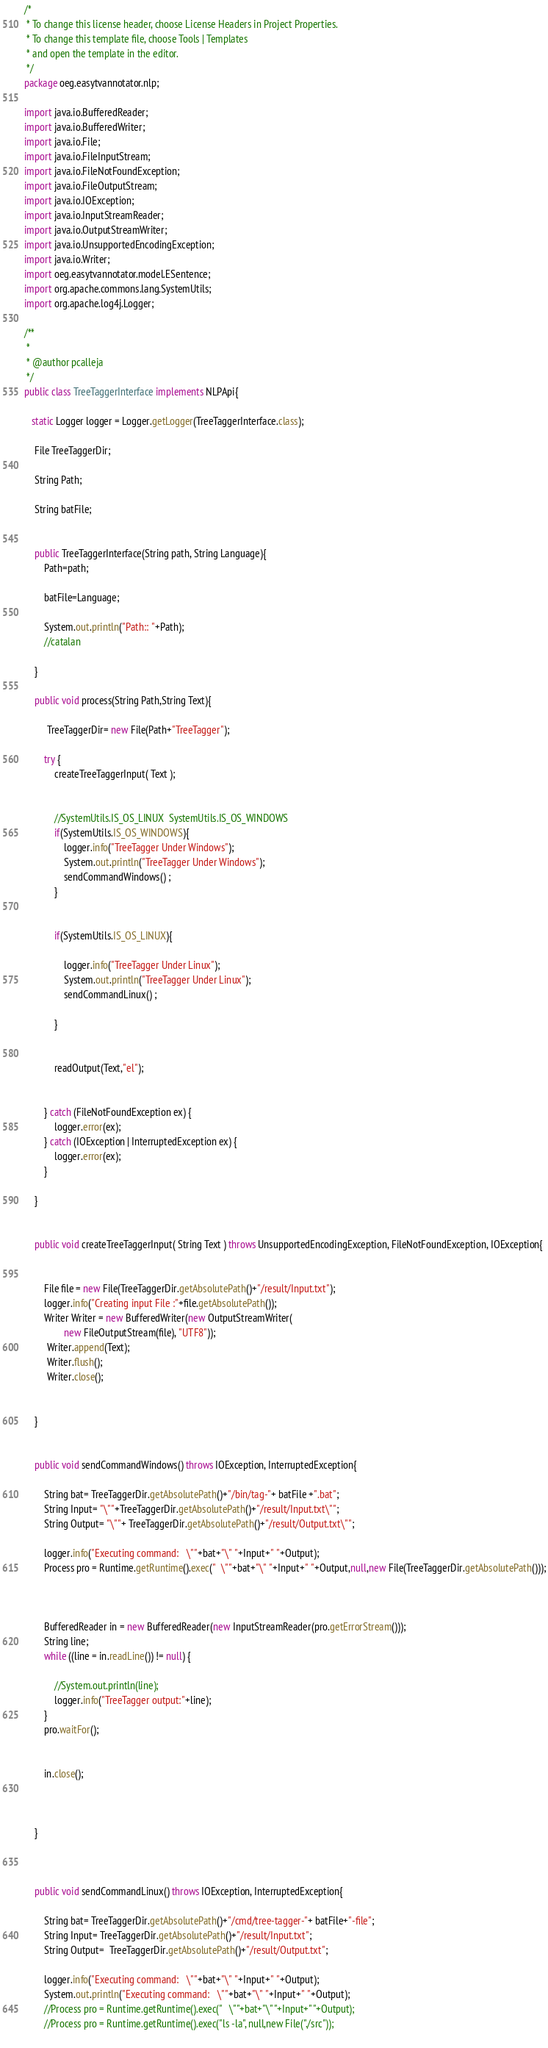Convert code to text. <code><loc_0><loc_0><loc_500><loc_500><_Java_>/*
 * To change this license header, choose License Headers in Project Properties.
 * To change this template file, choose Tools | Templates
 * and open the template in the editor.
 */
package oeg.easytvannotator.nlp;

import java.io.BufferedReader;
import java.io.BufferedWriter;
import java.io.File;
import java.io.FileInputStream;
import java.io.FileNotFoundException;
import java.io.FileOutputStream;
import java.io.IOException;
import java.io.InputStreamReader;
import java.io.OutputStreamWriter;
import java.io.UnsupportedEncodingException;
import java.io.Writer;
import oeg.easytvannotator.model.ESentence;
import org.apache.commons.lang.SystemUtils;
import org.apache.log4j.Logger;

/**
 *
 * @author pcalleja
 */
public class TreeTaggerInterface implements NLPApi{
    
   static Logger logger = Logger.getLogger(TreeTaggerInterface.class);
    
    File TreeTaggerDir;
    
    String Path;
    
    String batFile;
    
    
    public TreeTaggerInterface(String path, String Language){
        Path=path;
        
        batFile=Language;
        
        System.out.println("Path:: "+Path);
        //catalan
    
    }
    
    public void process(String Path,String Text){
    
         TreeTaggerDir= new File(Path+"TreeTagger");
         
        try {
            createTreeTaggerInput( Text );
            
            
            //SystemUtils.IS_OS_LINUX  SystemUtils.IS_OS_WINDOWS
            if(SystemUtils.IS_OS_WINDOWS){
                logger.info("TreeTagger Under Windows");
                System.out.println("TreeTagger Under Windows");
                sendCommandWindows() ;
            }
            
            
            if(SystemUtils.IS_OS_LINUX){
                
                logger.info("TreeTagger Under Linux");
                System.out.println("TreeTagger Under Linux");
                sendCommandLinux() ;
            
            }
            
            
            readOutput(Text,"el");
            
            
        } catch (FileNotFoundException ex) {
            logger.error(ex);
        } catch (IOException | InterruptedException ex) {
            logger.error(ex);
        }
        
    }
    
    
    public void createTreeTaggerInput( String Text ) throws UnsupportedEncodingException, FileNotFoundException, IOException{
    
        
        File file = new File(TreeTaggerDir.getAbsolutePath()+"/result/Input.txt");
        logger.info("Creating input File :"+file.getAbsolutePath());
        Writer Writer = new BufferedWriter(new OutputStreamWriter(
                new FileOutputStream(file), "UTF8"));
         Writer.append(Text);
         Writer.flush();
         Writer.close();
         
         
    }
    
    
    public void sendCommandWindows() throws IOException, InterruptedException{
      
        String bat= TreeTaggerDir.getAbsolutePath()+"/bin/tag-"+ batFile +".bat";
        String Input= "\""+TreeTaggerDir.getAbsolutePath()+"/result/Input.txt\"";
        String Output= "\""+ TreeTaggerDir.getAbsolutePath()+"/result/Output.txt\"";
        
        logger.info("Executing command:   \""+bat+"\" "+Input+" "+Output);
        Process pro = Runtime.getRuntime().exec("  \""+bat+"\" "+Input+" "+Output,null,new File(TreeTaggerDir.getAbsolutePath()));

        
       
        BufferedReader in = new BufferedReader(new InputStreamReader(pro.getErrorStream()));
        String line;
        while ((line = in.readLine()) != null) {
          
            //System.out.println(line);
            logger.info("TreeTagger output:"+line);
        }
        pro.waitFor();
       

        in.close();


    
    }
    
    
    
    public void sendCommandLinux() throws IOException, InterruptedException{
      
        String bat= TreeTaggerDir.getAbsolutePath()+"/cmd/tree-tagger-"+ batFile+"-file";
        String Input= TreeTaggerDir.getAbsolutePath()+"/result/Input.txt";
        String Output=  TreeTaggerDir.getAbsolutePath()+"/result/Output.txt";
        
        logger.info("Executing command:   \""+bat+"\" "+Input+" "+Output);
        System.out.println("Executing command:   \""+bat+"\" "+Input+" "+Output);
        //Process pro = Runtime.getRuntime().exec("   \""+bat+"\" "+Input+" "+Output);
        //Process pro = Runtime.getRuntime().exec("ls -la", null,new File("./src"));
       </code> 